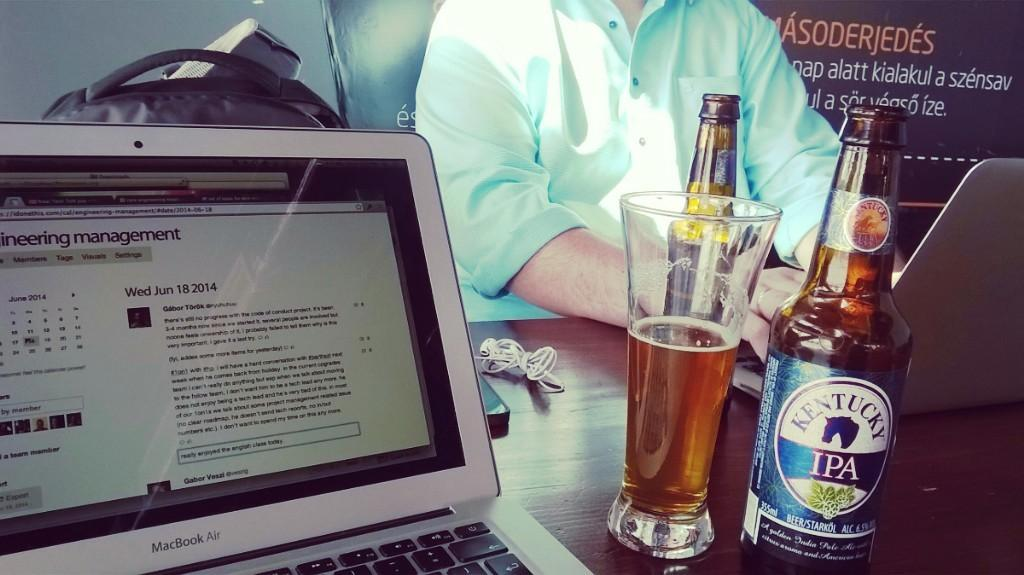<image>
Give a short and clear explanation of the subsequent image. The Kentucky beer sits next to the laptop 